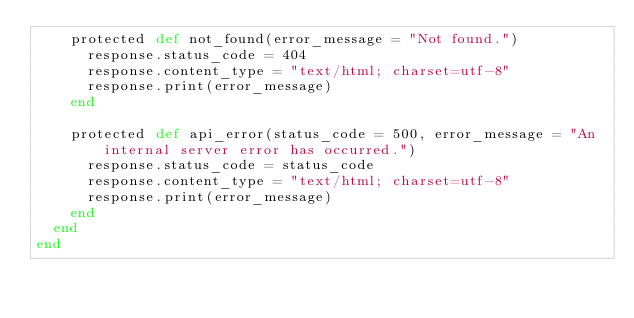<code> <loc_0><loc_0><loc_500><loc_500><_Crystal_>    protected def not_found(error_message = "Not found.")
      response.status_code = 404
      response.content_type = "text/html; charset=utf-8"
      response.print(error_message)
    end

    protected def api_error(status_code = 500, error_message = "An internal server error has occurred.")
      response.status_code = status_code
      response.content_type = "text/html; charset=utf-8"
      response.print(error_message)
    end
  end
end
</code> 